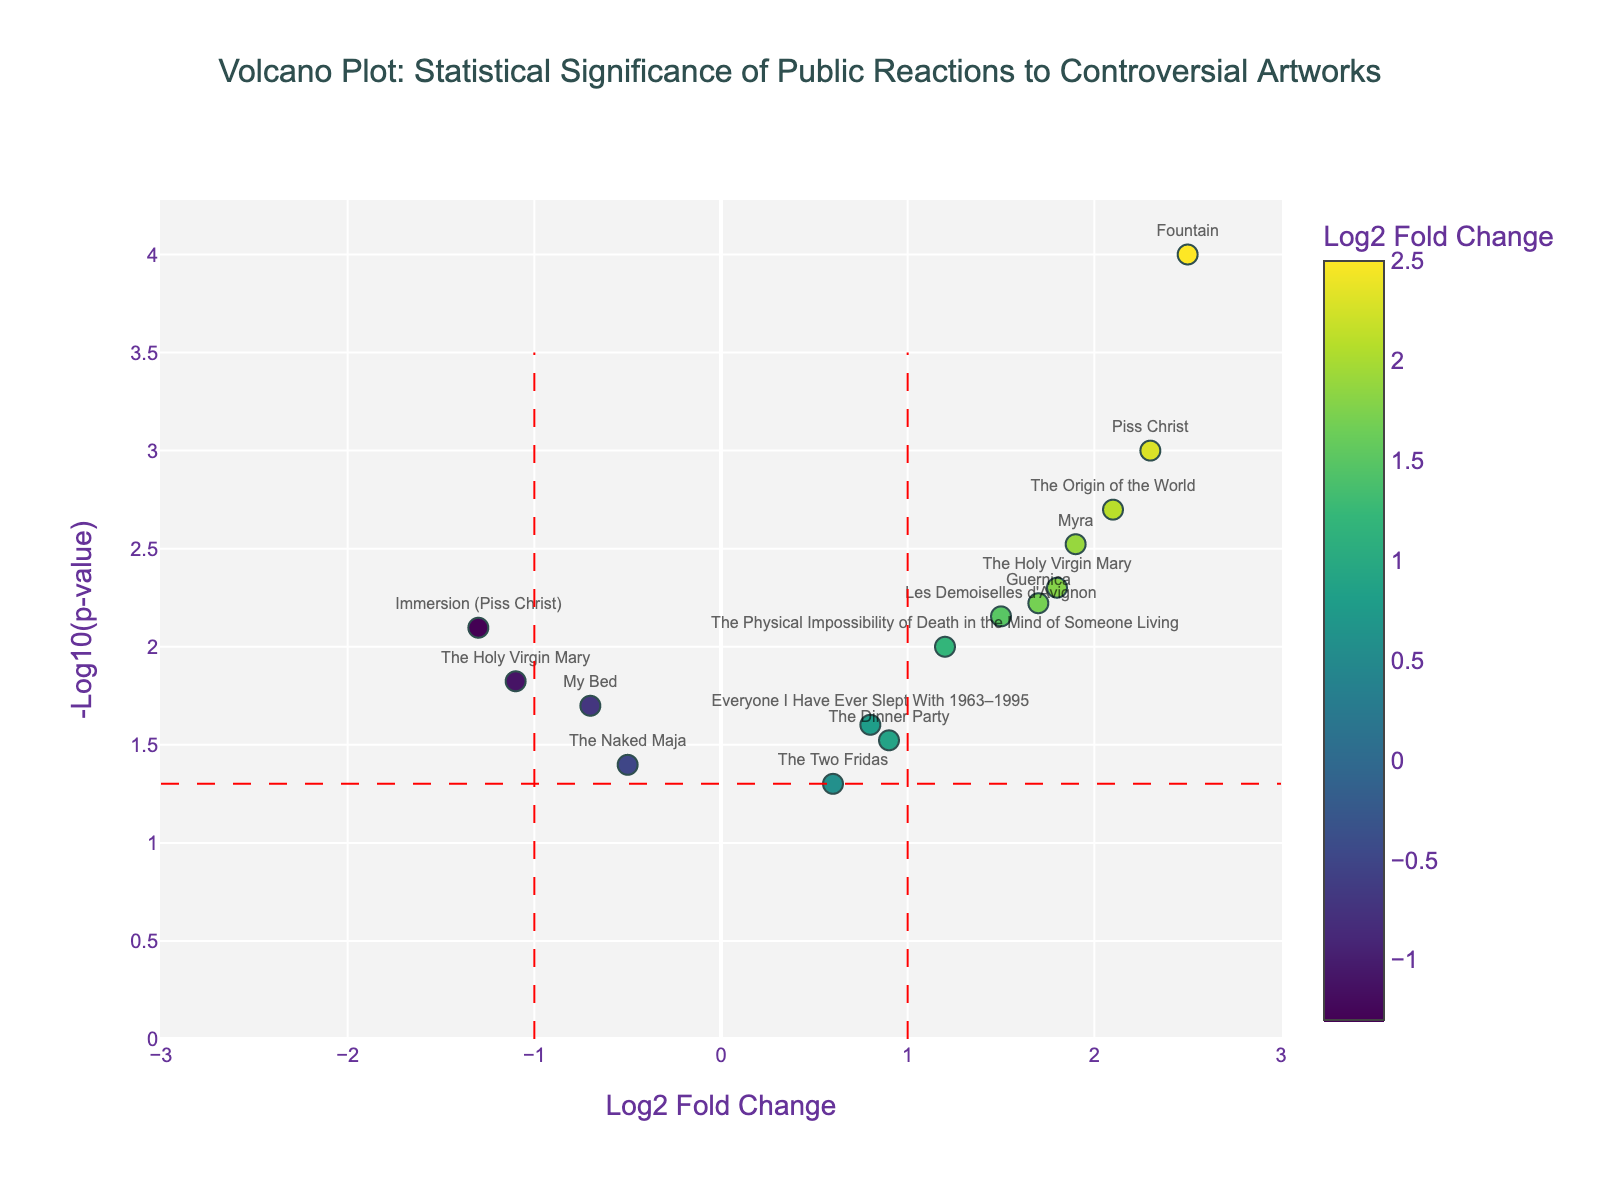How many artworks are represented in the plot? Count all the names mentioned in the plot. Each text label represents an artwork.
Answer: 15 What does the x-axis represent in this plot? Refer to the axis title provided in the plot. The label mentions 'Log2 Fold Change'.
Answer: Log2 Fold Change What does a -log10(p-value) of 3 correspond to approximately in terms of the original p-value? Use the inverse of the -log10 transformation. If -log10(p-value) is 3, then p-value is 10^-3.
Answer: 0.001 Which artwork has the highest log2 fold change? Look for the point with the highest value on the x-axis (rightmost point). The artwork label is "Fountain".
Answer: "Fountain" Which artwork has the lowest p-value? The lowest p-value corresponds to the highest value on the y-axis. Identify the artwork label at the topmost point.
Answer: "Fountain" How many artworks show a statistically significant reaction (p-value < 0.05)? Identify all points above the red dashed line that indicates the p-value threshold (-log10(0.05)). Count them.
Answer: 10 Which artworks exhibit a negative log2 fold change and are statistically significant? Look for points to the left of the leftmost red dashed vertical line (negative log2 fold change) and above the red dashed horizontal line (p-value < 0.05). Identify the labels.
Answer: "My Bed", "The Holy Virgin Mary", "Immersion (Piss Christ)" Compare the p-values of "Piss Christ" and "The Origin of the World". Which one has a lower p-value? Compare their y-axis positions. Higher y-axis means lower p-value. "Piss Christ" is slightly higher.
Answer: "Piss Christ" What can you infer from artworks with a log2 fold change less than -1? Look at points with log2 fold change less than -1 (left side of the corresponding threshold line). Determine the nature of these points. These artworks generally have decreased positive reactions or increased negative reactions.
Answer: Decreased positive/increased negative reactions Which artwork has a log2 fold change close to zero but is statistically significant? Find points near the center of the x-axis (log2 fold change ~ 0) and above the red dashed y-axis line. Label should be near zero.
Answer: "The Two Fridas" 